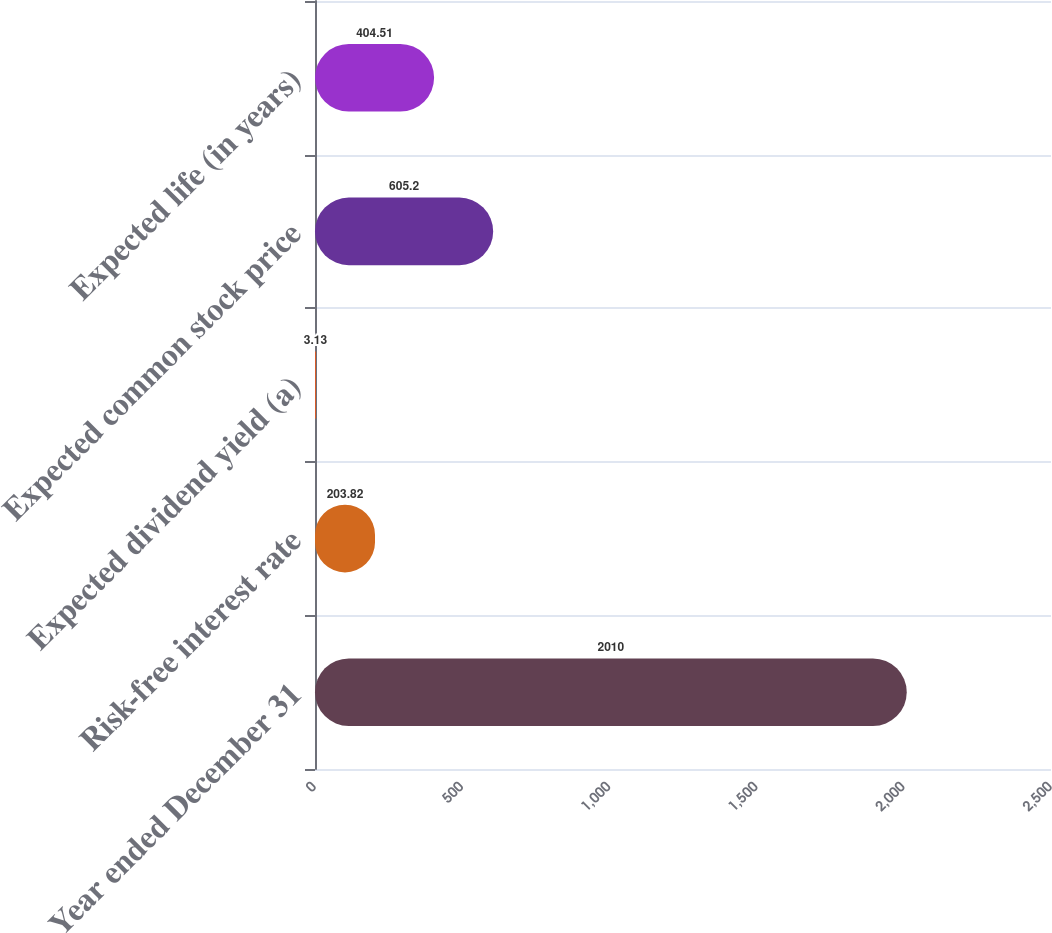Convert chart. <chart><loc_0><loc_0><loc_500><loc_500><bar_chart><fcel>Year ended December 31<fcel>Risk-free interest rate<fcel>Expected dividend yield (a)<fcel>Expected common stock price<fcel>Expected life (in years)<nl><fcel>2010<fcel>203.82<fcel>3.13<fcel>605.2<fcel>404.51<nl></chart> 